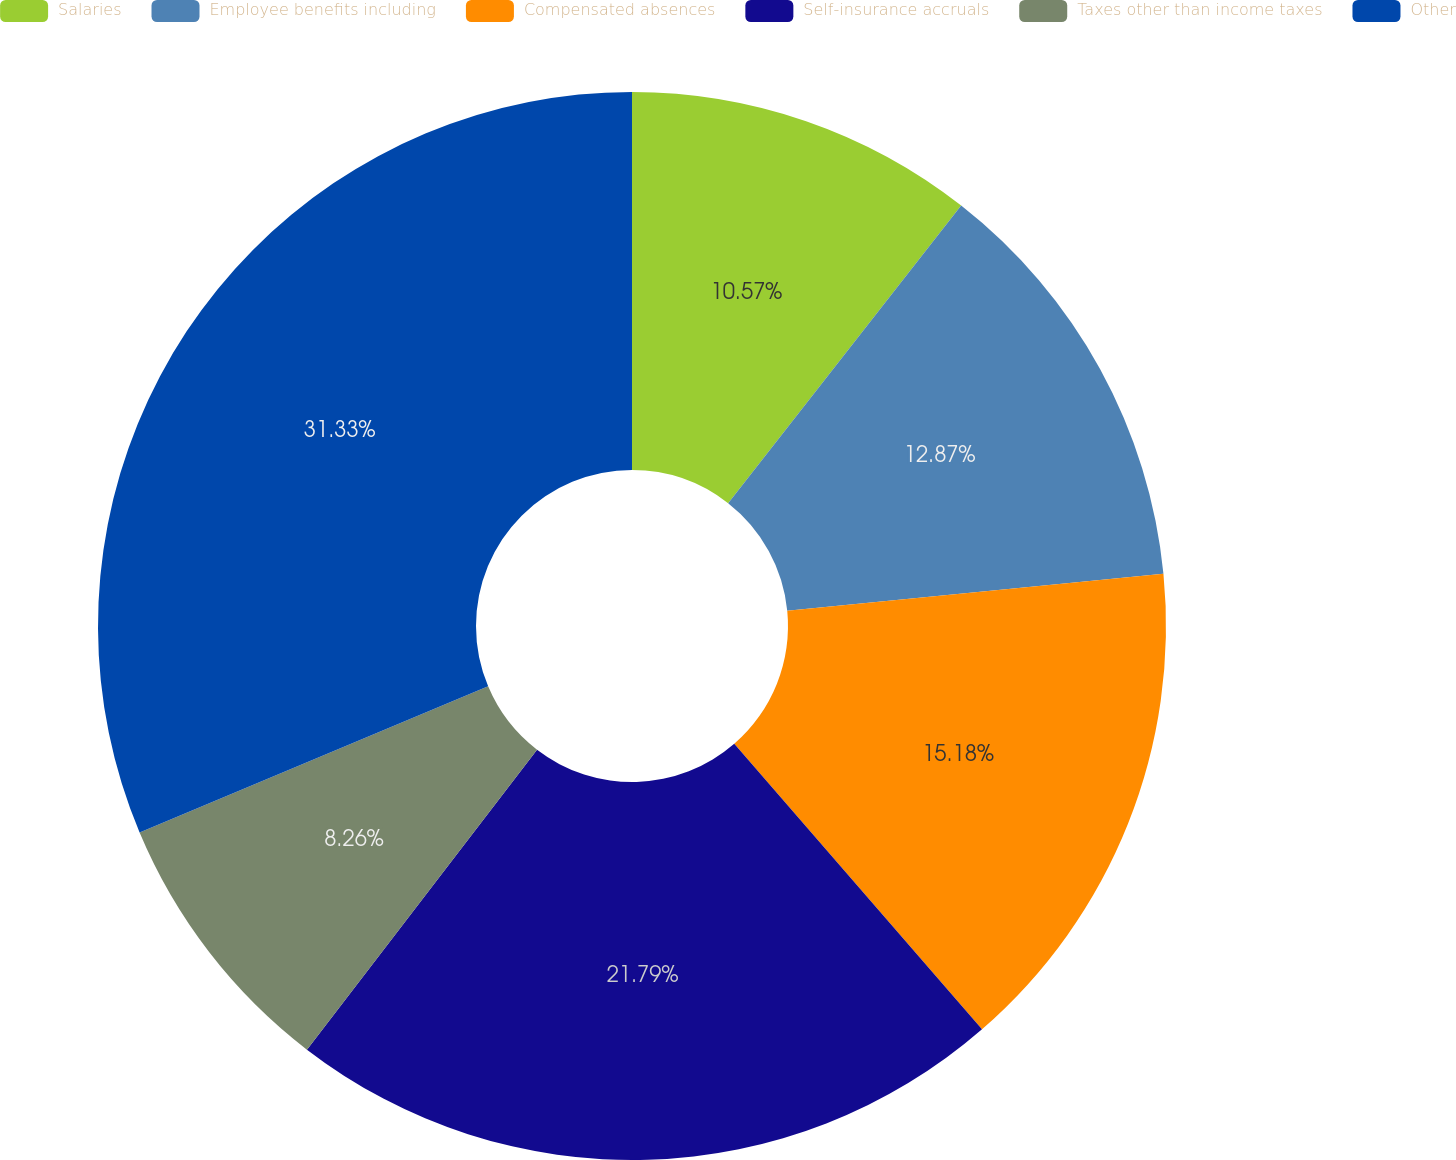Convert chart. <chart><loc_0><loc_0><loc_500><loc_500><pie_chart><fcel>Salaries<fcel>Employee benefits including<fcel>Compensated absences<fcel>Self-insurance accruals<fcel>Taxes other than income taxes<fcel>Other<nl><fcel>10.57%<fcel>12.87%<fcel>15.18%<fcel>21.79%<fcel>8.26%<fcel>31.32%<nl></chart> 